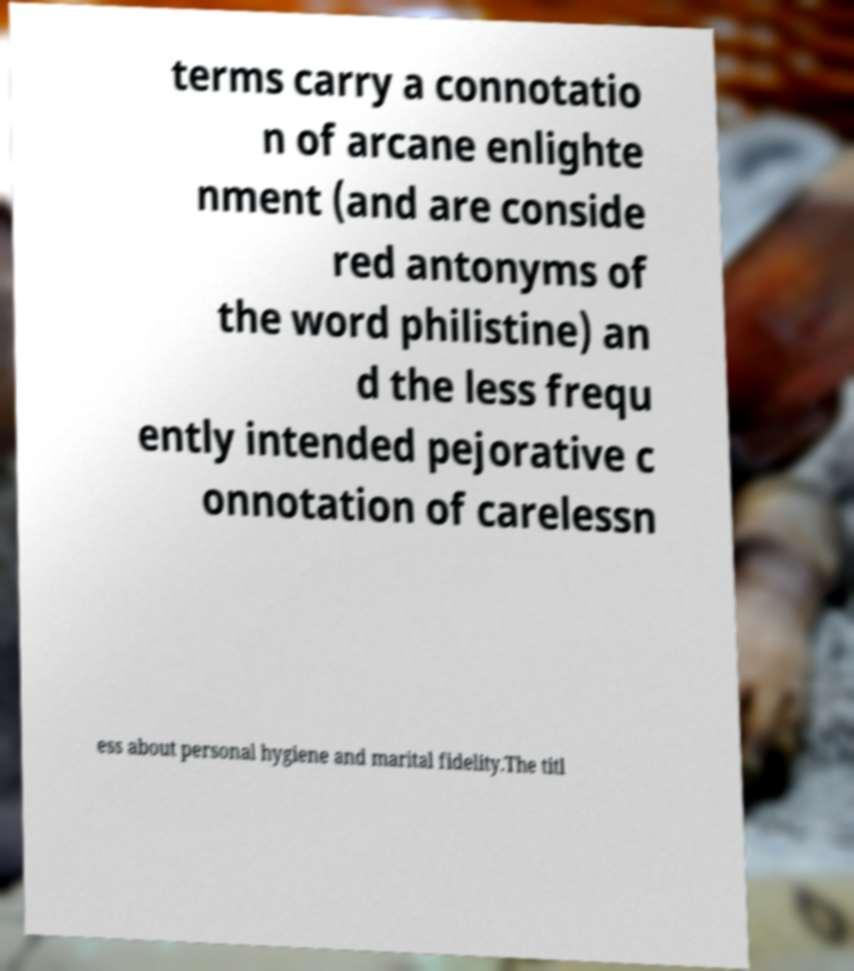There's text embedded in this image that I need extracted. Can you transcribe it verbatim? terms carry a connotatio n of arcane enlighte nment (and are conside red antonyms of the word philistine) an d the less frequ ently intended pejorative c onnotation of carelessn ess about personal hygiene and marital fidelity.The titl 